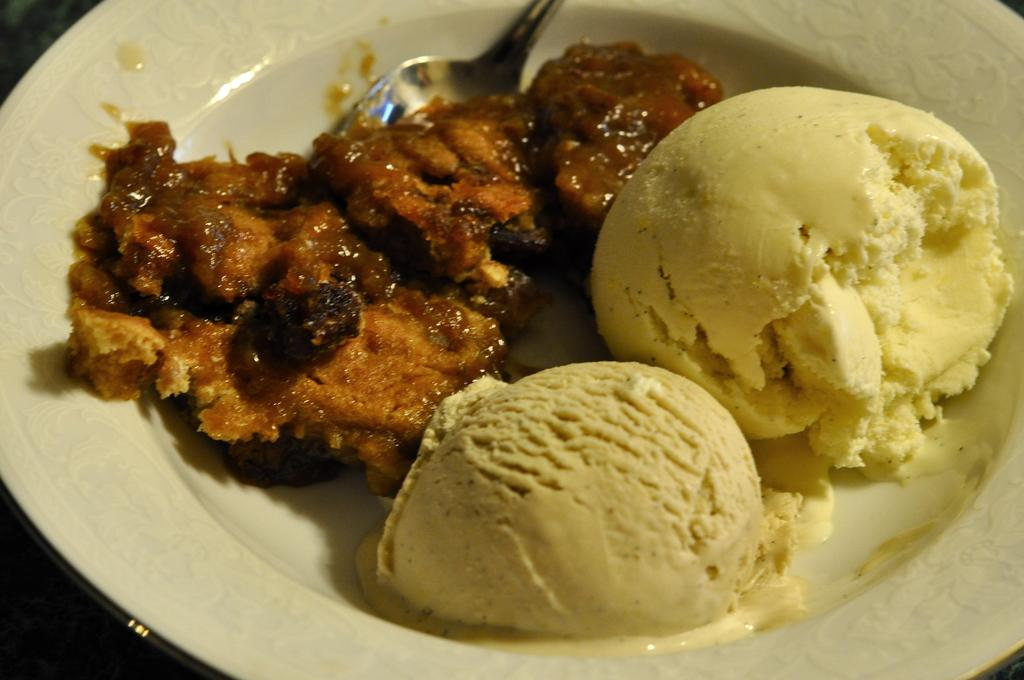What is on the plate in the image? The plate contains two scoops of ice cream. What else can be seen near the plate? There is a sweet beside the plate. What is used to eat the ice cream in the image? There is a spoon in the sweet. What type of game is being played in the image? There is no game present in the image; it features a plate with ice cream, a sweet, and a spoon. How is the pencil used in the image? There is no pencil present in the image. 